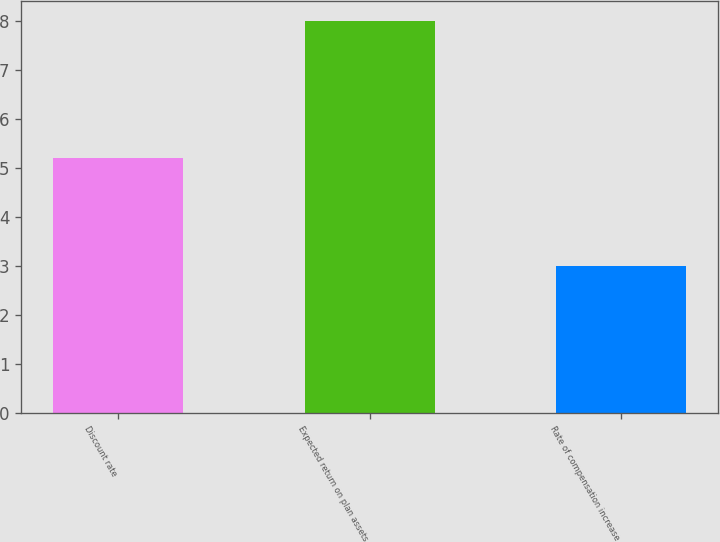Convert chart. <chart><loc_0><loc_0><loc_500><loc_500><bar_chart><fcel>Discount rate<fcel>Expected return on plan assets<fcel>Rate of compensation increase<nl><fcel>5.2<fcel>8<fcel>3<nl></chart> 